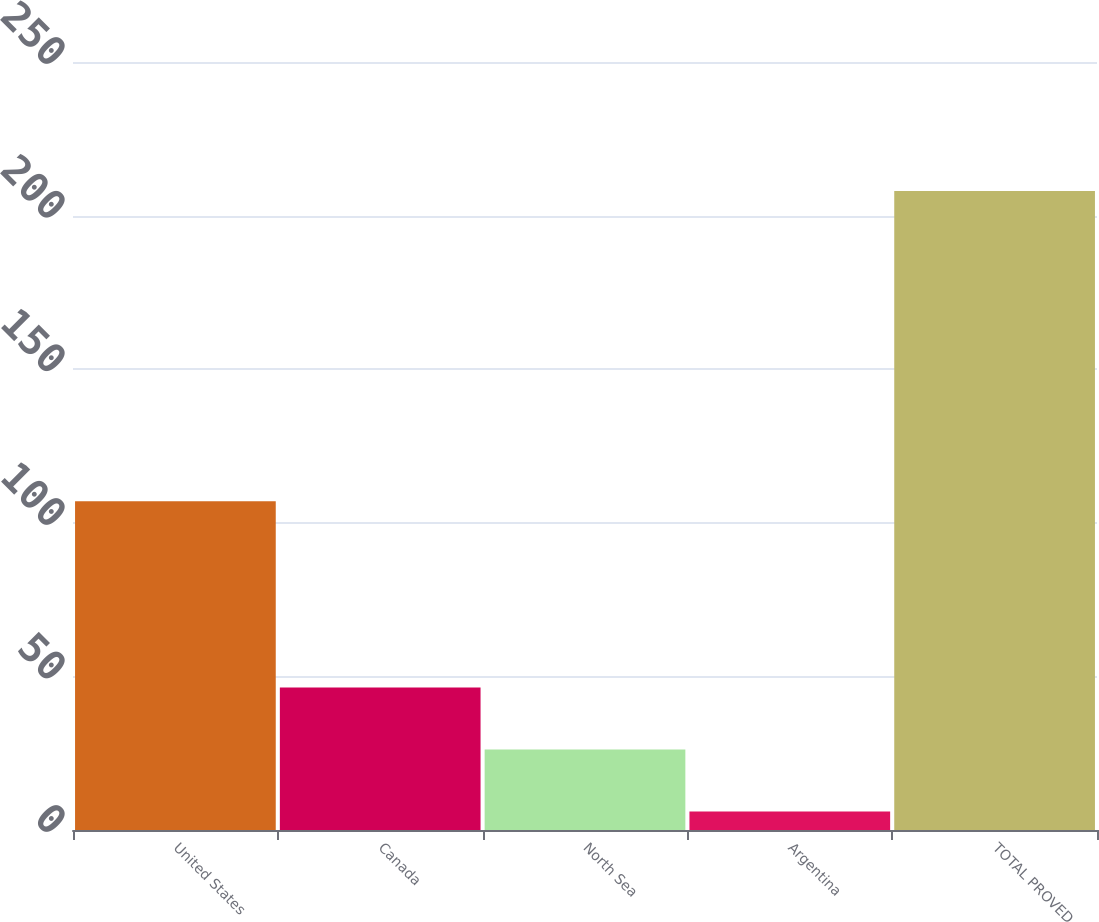<chart> <loc_0><loc_0><loc_500><loc_500><bar_chart><fcel>United States<fcel>Canada<fcel>North Sea<fcel>Argentina<fcel>TOTAL PROVED<nl><fcel>107<fcel>46.4<fcel>26.2<fcel>6<fcel>208<nl></chart> 